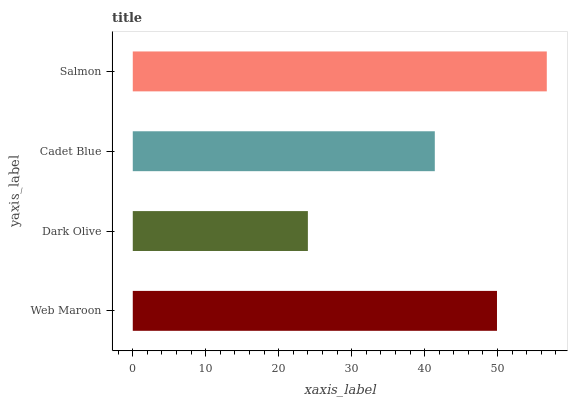Is Dark Olive the minimum?
Answer yes or no. Yes. Is Salmon the maximum?
Answer yes or no. Yes. Is Cadet Blue the minimum?
Answer yes or no. No. Is Cadet Blue the maximum?
Answer yes or no. No. Is Cadet Blue greater than Dark Olive?
Answer yes or no. Yes. Is Dark Olive less than Cadet Blue?
Answer yes or no. Yes. Is Dark Olive greater than Cadet Blue?
Answer yes or no. No. Is Cadet Blue less than Dark Olive?
Answer yes or no. No. Is Web Maroon the high median?
Answer yes or no. Yes. Is Cadet Blue the low median?
Answer yes or no. Yes. Is Cadet Blue the high median?
Answer yes or no. No. Is Salmon the low median?
Answer yes or no. No. 